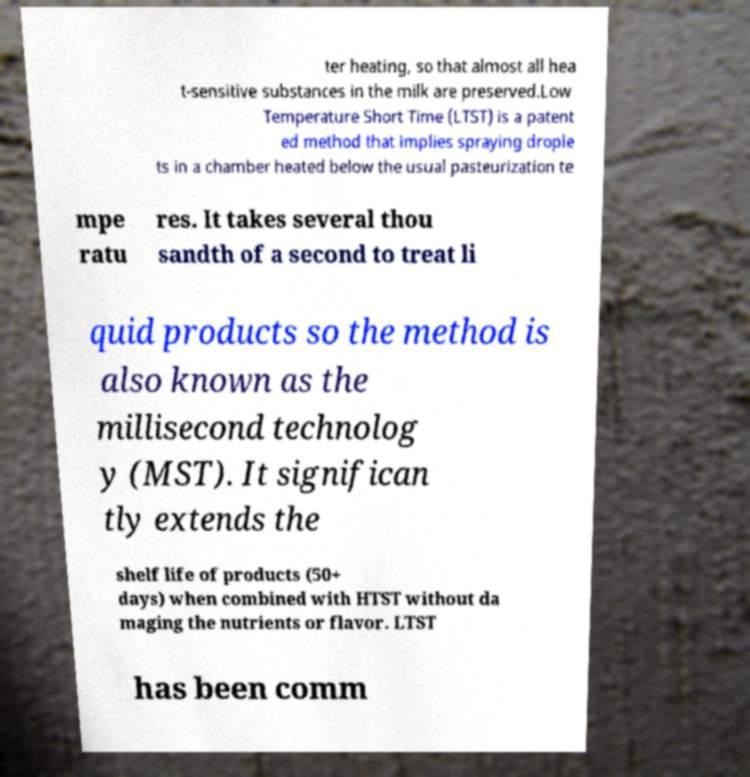Can you accurately transcribe the text from the provided image for me? ter heating, so that almost all hea t-sensitive substances in the milk are preserved.Low Temperature Short Time (LTST) is a patent ed method that implies spraying drople ts in a chamber heated below the usual pasteurization te mpe ratu res. It takes several thou sandth of a second to treat li quid products so the method is also known as the millisecond technolog y (MST). It significan tly extends the shelf life of products (50+ days) when combined with HTST without da maging the nutrients or flavor. LTST has been comm 